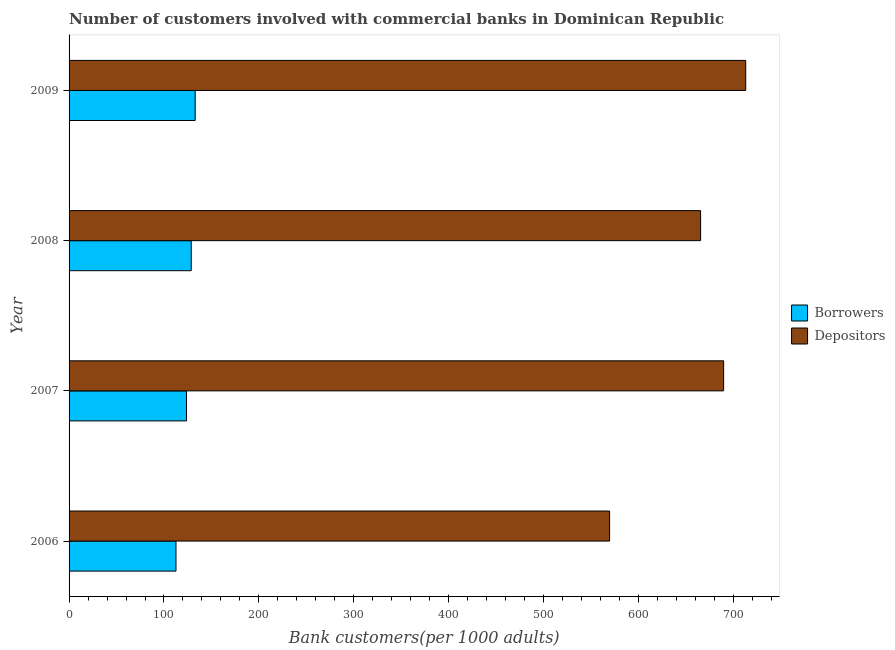Are the number of bars on each tick of the Y-axis equal?
Offer a terse response. Yes. How many bars are there on the 4th tick from the top?
Give a very brief answer. 2. In how many cases, is the number of bars for a given year not equal to the number of legend labels?
Offer a terse response. 0. What is the number of borrowers in 2007?
Offer a terse response. 123.75. Across all years, what is the maximum number of borrowers?
Your answer should be compact. 132.88. Across all years, what is the minimum number of depositors?
Your response must be concise. 569.55. What is the total number of borrowers in the graph?
Give a very brief answer. 498.01. What is the difference between the number of depositors in 2008 and that in 2009?
Offer a very short reply. -47.54. What is the difference between the number of borrowers in 2006 and the number of depositors in 2007?
Ensure brevity in your answer.  -577.04. What is the average number of depositors per year?
Offer a terse response. 659.41. In the year 2006, what is the difference between the number of borrowers and number of depositors?
Give a very brief answer. -456.9. In how many years, is the number of borrowers greater than 140 ?
Offer a terse response. 0. What is the difference between the highest and the second highest number of borrowers?
Your answer should be very brief. 4.14. What is the difference between the highest and the lowest number of depositors?
Make the answer very short. 143.41. Is the sum of the number of borrowers in 2006 and 2007 greater than the maximum number of depositors across all years?
Keep it short and to the point. No. What does the 2nd bar from the top in 2008 represents?
Offer a very short reply. Borrowers. What does the 1st bar from the bottom in 2006 represents?
Offer a terse response. Borrowers. How many years are there in the graph?
Your answer should be compact. 4. What is the difference between two consecutive major ticks on the X-axis?
Provide a succinct answer. 100. Does the graph contain grids?
Your response must be concise. No. How many legend labels are there?
Keep it short and to the point. 2. What is the title of the graph?
Provide a short and direct response. Number of customers involved with commercial banks in Dominican Republic. What is the label or title of the X-axis?
Your answer should be compact. Bank customers(per 1000 adults). What is the Bank customers(per 1000 adults) of Borrowers in 2006?
Provide a succinct answer. 112.65. What is the Bank customers(per 1000 adults) in Depositors in 2006?
Your answer should be very brief. 569.55. What is the Bank customers(per 1000 adults) of Borrowers in 2007?
Offer a terse response. 123.75. What is the Bank customers(per 1000 adults) of Depositors in 2007?
Provide a short and direct response. 689.69. What is the Bank customers(per 1000 adults) in Borrowers in 2008?
Offer a terse response. 128.74. What is the Bank customers(per 1000 adults) of Depositors in 2008?
Keep it short and to the point. 665.43. What is the Bank customers(per 1000 adults) in Borrowers in 2009?
Your answer should be very brief. 132.88. What is the Bank customers(per 1000 adults) of Depositors in 2009?
Provide a succinct answer. 712.97. Across all years, what is the maximum Bank customers(per 1000 adults) in Borrowers?
Offer a terse response. 132.88. Across all years, what is the maximum Bank customers(per 1000 adults) of Depositors?
Ensure brevity in your answer.  712.97. Across all years, what is the minimum Bank customers(per 1000 adults) of Borrowers?
Provide a short and direct response. 112.65. Across all years, what is the minimum Bank customers(per 1000 adults) in Depositors?
Give a very brief answer. 569.55. What is the total Bank customers(per 1000 adults) of Borrowers in the graph?
Your response must be concise. 498.01. What is the total Bank customers(per 1000 adults) in Depositors in the graph?
Provide a succinct answer. 2637.64. What is the difference between the Bank customers(per 1000 adults) in Borrowers in 2006 and that in 2007?
Keep it short and to the point. -11.1. What is the difference between the Bank customers(per 1000 adults) of Depositors in 2006 and that in 2007?
Provide a succinct answer. -120.14. What is the difference between the Bank customers(per 1000 adults) of Borrowers in 2006 and that in 2008?
Your answer should be compact. -16.09. What is the difference between the Bank customers(per 1000 adults) of Depositors in 2006 and that in 2008?
Keep it short and to the point. -95.87. What is the difference between the Bank customers(per 1000 adults) in Borrowers in 2006 and that in 2009?
Offer a terse response. -20.23. What is the difference between the Bank customers(per 1000 adults) in Depositors in 2006 and that in 2009?
Your response must be concise. -143.41. What is the difference between the Bank customers(per 1000 adults) in Borrowers in 2007 and that in 2008?
Your answer should be very brief. -4.99. What is the difference between the Bank customers(per 1000 adults) in Depositors in 2007 and that in 2008?
Ensure brevity in your answer.  24.27. What is the difference between the Bank customers(per 1000 adults) in Borrowers in 2007 and that in 2009?
Your answer should be very brief. -9.13. What is the difference between the Bank customers(per 1000 adults) in Depositors in 2007 and that in 2009?
Offer a very short reply. -23.27. What is the difference between the Bank customers(per 1000 adults) in Borrowers in 2008 and that in 2009?
Give a very brief answer. -4.14. What is the difference between the Bank customers(per 1000 adults) in Depositors in 2008 and that in 2009?
Your response must be concise. -47.54. What is the difference between the Bank customers(per 1000 adults) of Borrowers in 2006 and the Bank customers(per 1000 adults) of Depositors in 2007?
Your response must be concise. -577.04. What is the difference between the Bank customers(per 1000 adults) of Borrowers in 2006 and the Bank customers(per 1000 adults) of Depositors in 2008?
Give a very brief answer. -552.78. What is the difference between the Bank customers(per 1000 adults) of Borrowers in 2006 and the Bank customers(per 1000 adults) of Depositors in 2009?
Keep it short and to the point. -600.32. What is the difference between the Bank customers(per 1000 adults) in Borrowers in 2007 and the Bank customers(per 1000 adults) in Depositors in 2008?
Provide a succinct answer. -541.68. What is the difference between the Bank customers(per 1000 adults) in Borrowers in 2007 and the Bank customers(per 1000 adults) in Depositors in 2009?
Keep it short and to the point. -589.22. What is the difference between the Bank customers(per 1000 adults) of Borrowers in 2008 and the Bank customers(per 1000 adults) of Depositors in 2009?
Provide a short and direct response. -584.23. What is the average Bank customers(per 1000 adults) of Borrowers per year?
Make the answer very short. 124.5. What is the average Bank customers(per 1000 adults) in Depositors per year?
Keep it short and to the point. 659.41. In the year 2006, what is the difference between the Bank customers(per 1000 adults) of Borrowers and Bank customers(per 1000 adults) of Depositors?
Ensure brevity in your answer.  -456.9. In the year 2007, what is the difference between the Bank customers(per 1000 adults) in Borrowers and Bank customers(per 1000 adults) in Depositors?
Keep it short and to the point. -565.95. In the year 2008, what is the difference between the Bank customers(per 1000 adults) in Borrowers and Bank customers(per 1000 adults) in Depositors?
Provide a succinct answer. -536.69. In the year 2009, what is the difference between the Bank customers(per 1000 adults) of Borrowers and Bank customers(per 1000 adults) of Depositors?
Your answer should be very brief. -580.09. What is the ratio of the Bank customers(per 1000 adults) in Borrowers in 2006 to that in 2007?
Provide a short and direct response. 0.91. What is the ratio of the Bank customers(per 1000 adults) in Depositors in 2006 to that in 2007?
Ensure brevity in your answer.  0.83. What is the ratio of the Bank customers(per 1000 adults) in Borrowers in 2006 to that in 2008?
Your answer should be very brief. 0.88. What is the ratio of the Bank customers(per 1000 adults) of Depositors in 2006 to that in 2008?
Make the answer very short. 0.86. What is the ratio of the Bank customers(per 1000 adults) in Borrowers in 2006 to that in 2009?
Provide a short and direct response. 0.85. What is the ratio of the Bank customers(per 1000 adults) of Depositors in 2006 to that in 2009?
Keep it short and to the point. 0.8. What is the ratio of the Bank customers(per 1000 adults) in Borrowers in 2007 to that in 2008?
Your response must be concise. 0.96. What is the ratio of the Bank customers(per 1000 adults) of Depositors in 2007 to that in 2008?
Provide a short and direct response. 1.04. What is the ratio of the Bank customers(per 1000 adults) of Borrowers in 2007 to that in 2009?
Your answer should be compact. 0.93. What is the ratio of the Bank customers(per 1000 adults) in Depositors in 2007 to that in 2009?
Offer a very short reply. 0.97. What is the ratio of the Bank customers(per 1000 adults) in Borrowers in 2008 to that in 2009?
Your answer should be very brief. 0.97. What is the difference between the highest and the second highest Bank customers(per 1000 adults) of Borrowers?
Give a very brief answer. 4.14. What is the difference between the highest and the second highest Bank customers(per 1000 adults) in Depositors?
Offer a very short reply. 23.27. What is the difference between the highest and the lowest Bank customers(per 1000 adults) in Borrowers?
Offer a terse response. 20.23. What is the difference between the highest and the lowest Bank customers(per 1000 adults) in Depositors?
Your answer should be very brief. 143.41. 